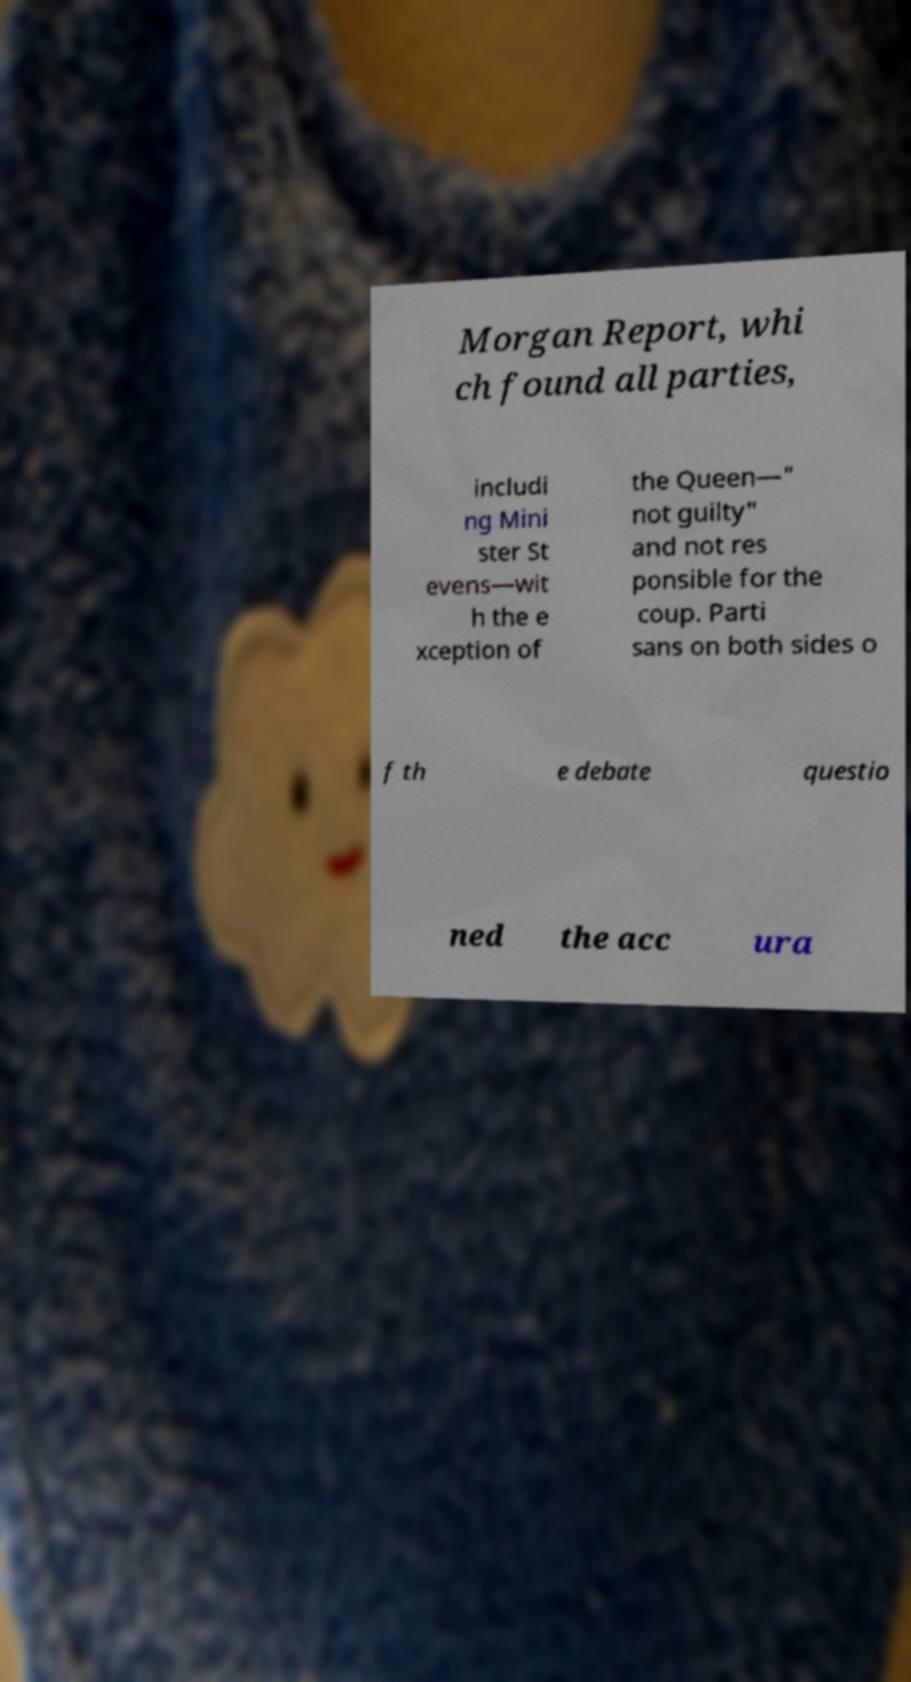Could you extract and type out the text from this image? Morgan Report, whi ch found all parties, includi ng Mini ster St evens—wit h the e xception of the Queen—" not guilty" and not res ponsible for the coup. Parti sans on both sides o f th e debate questio ned the acc ura 